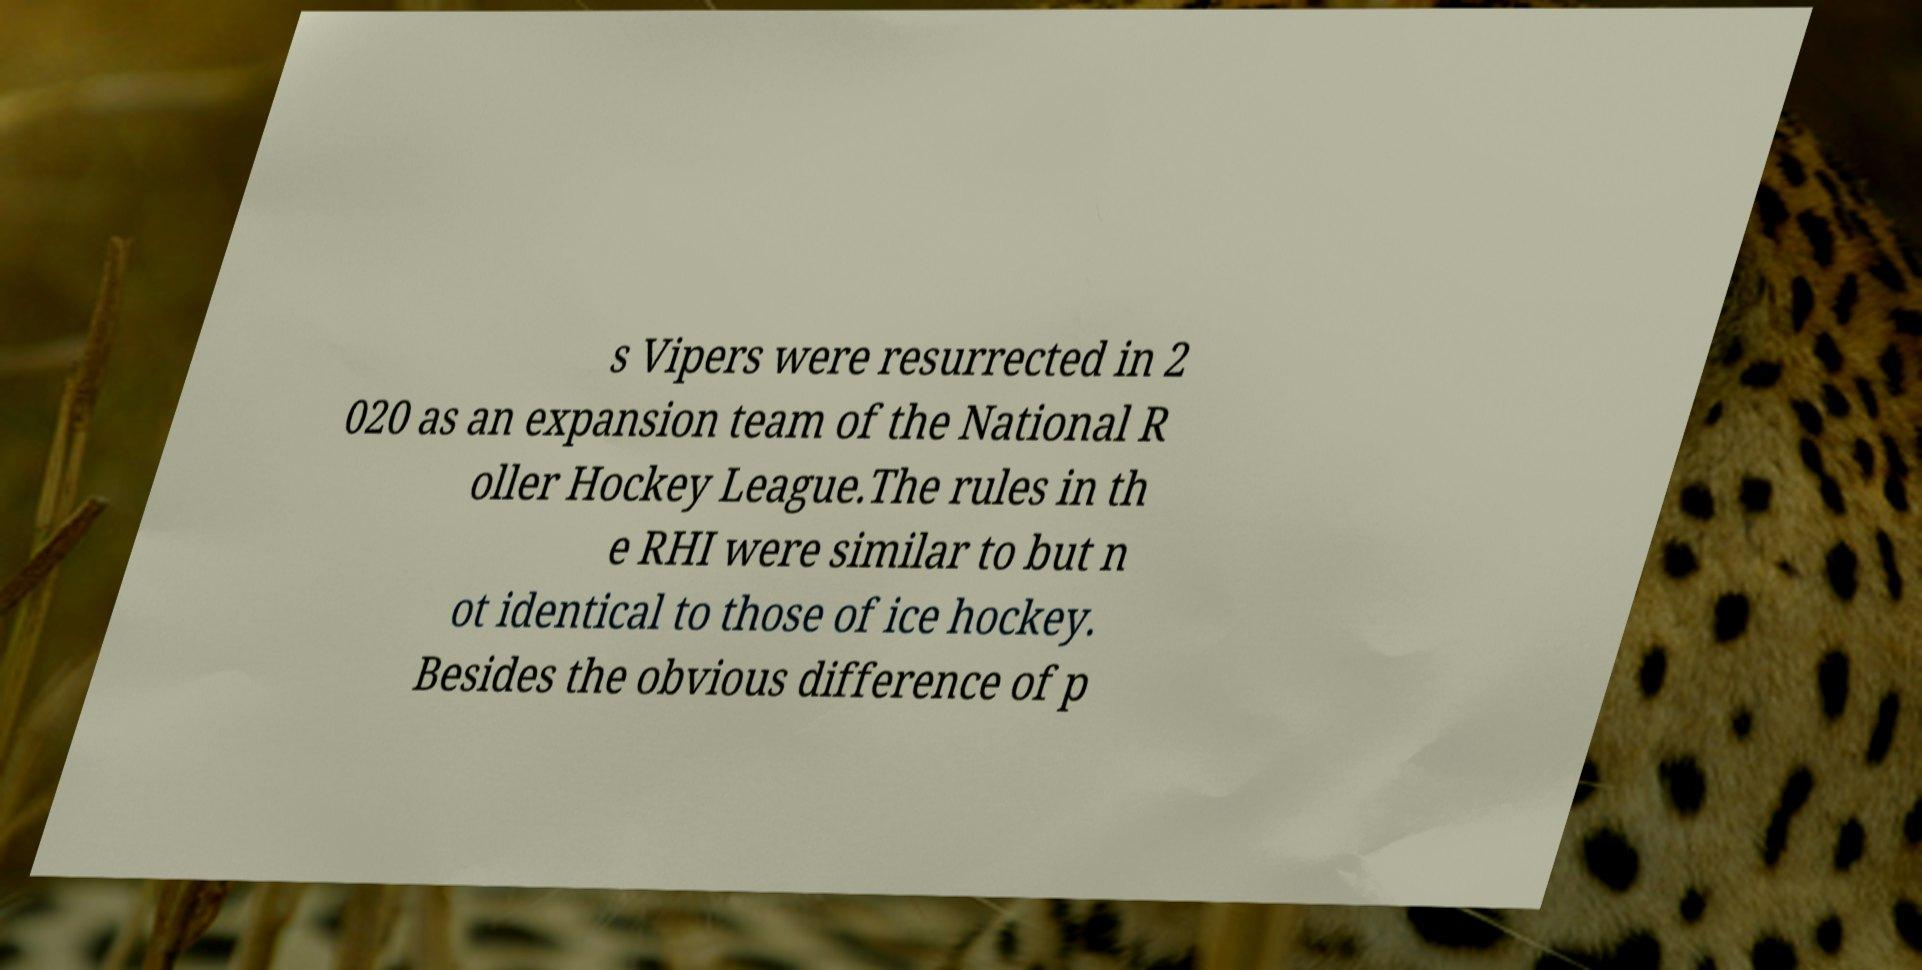For documentation purposes, I need the text within this image transcribed. Could you provide that? s Vipers were resurrected in 2 020 as an expansion team of the National R oller Hockey League.The rules in th e RHI were similar to but n ot identical to those of ice hockey. Besides the obvious difference of p 